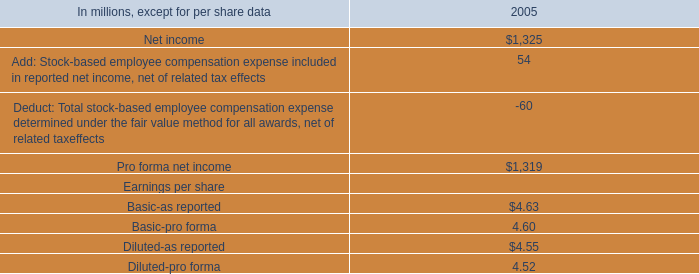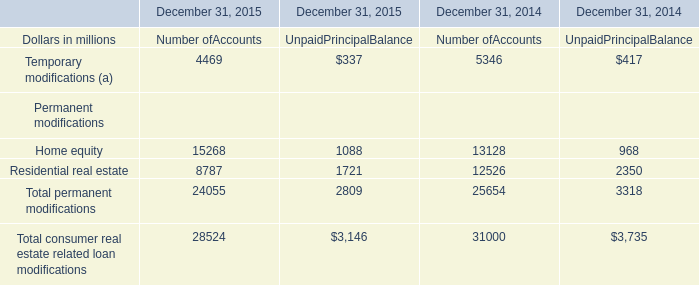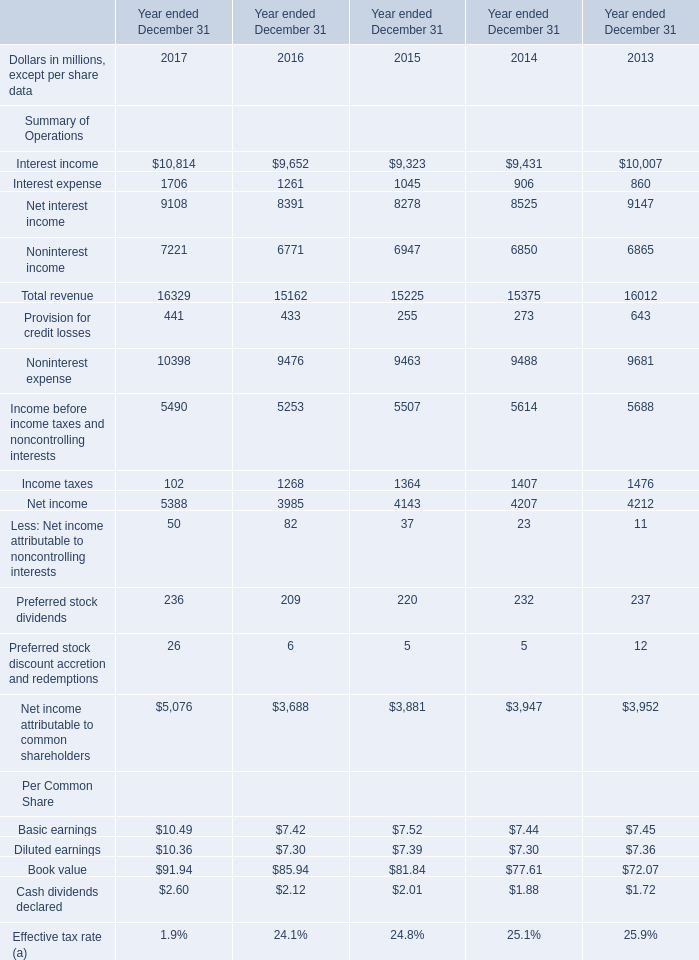What is the total amount of Pro forma net income of 2005, and Interest income of Year ended December 31 2014 ? 
Computations: (1319.0 + 9431.0)
Answer: 10750.0. 